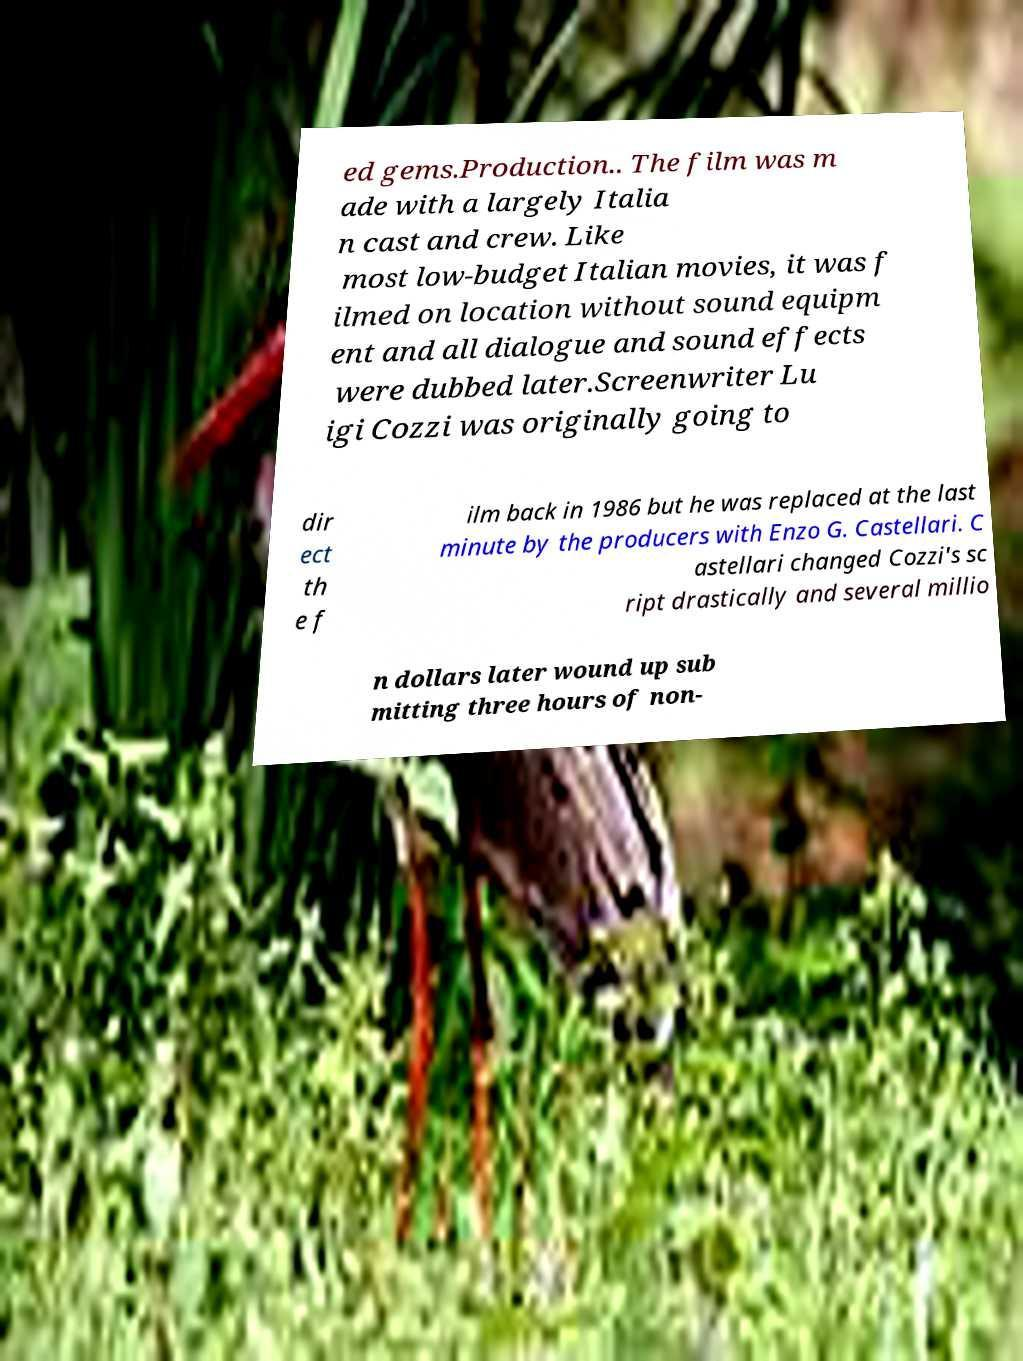Please read and relay the text visible in this image. What does it say? ed gems.Production.. The film was m ade with a largely Italia n cast and crew. Like most low-budget Italian movies, it was f ilmed on location without sound equipm ent and all dialogue and sound effects were dubbed later.Screenwriter Lu igi Cozzi was originally going to dir ect th e f ilm back in 1986 but he was replaced at the last minute by the producers with Enzo G. Castellari. C astellari changed Cozzi's sc ript drastically and several millio n dollars later wound up sub mitting three hours of non- 